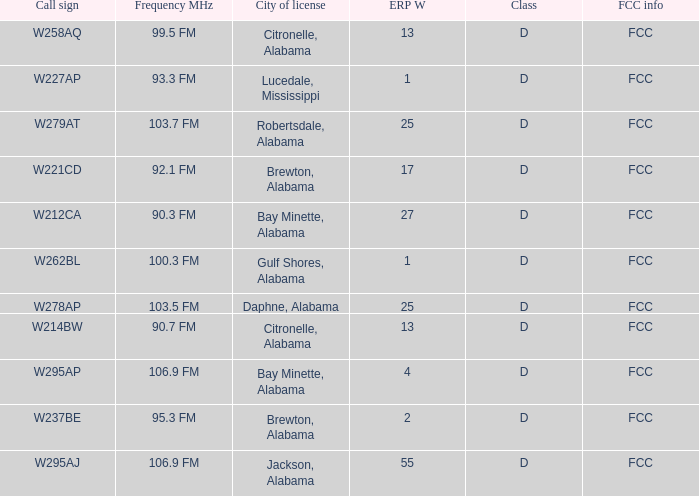Name the frequence MHz for ERP W of 55 106.9 FM. 